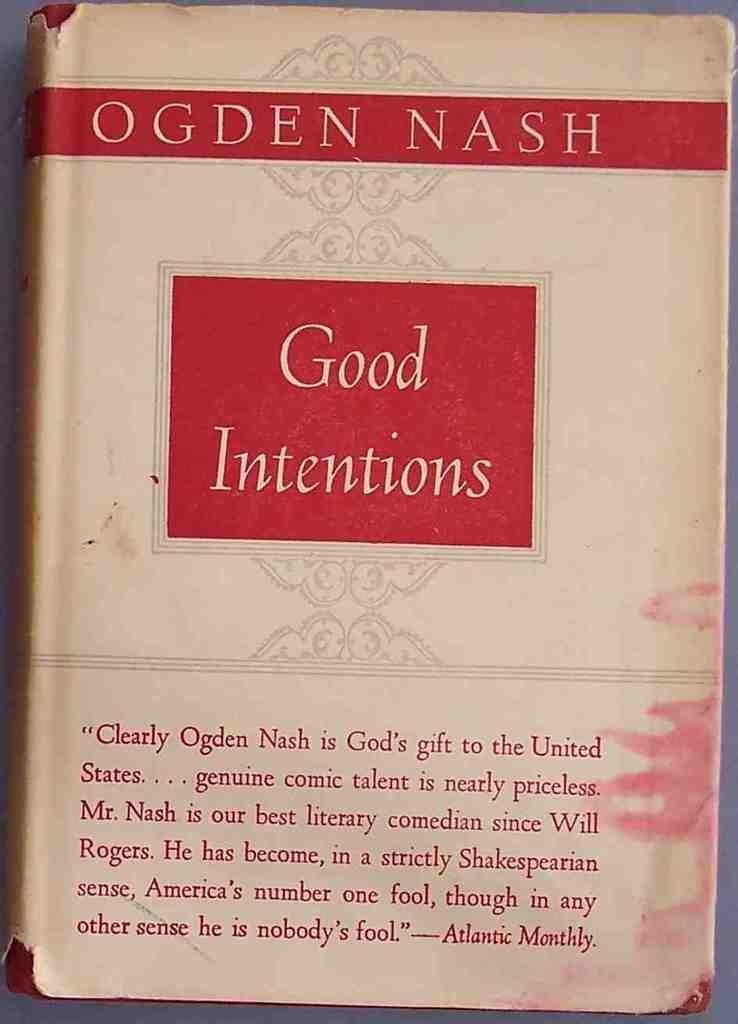Please provide a concise description of this image. In this image we can see a book which is placed on the surface. We can also see some text on it. 